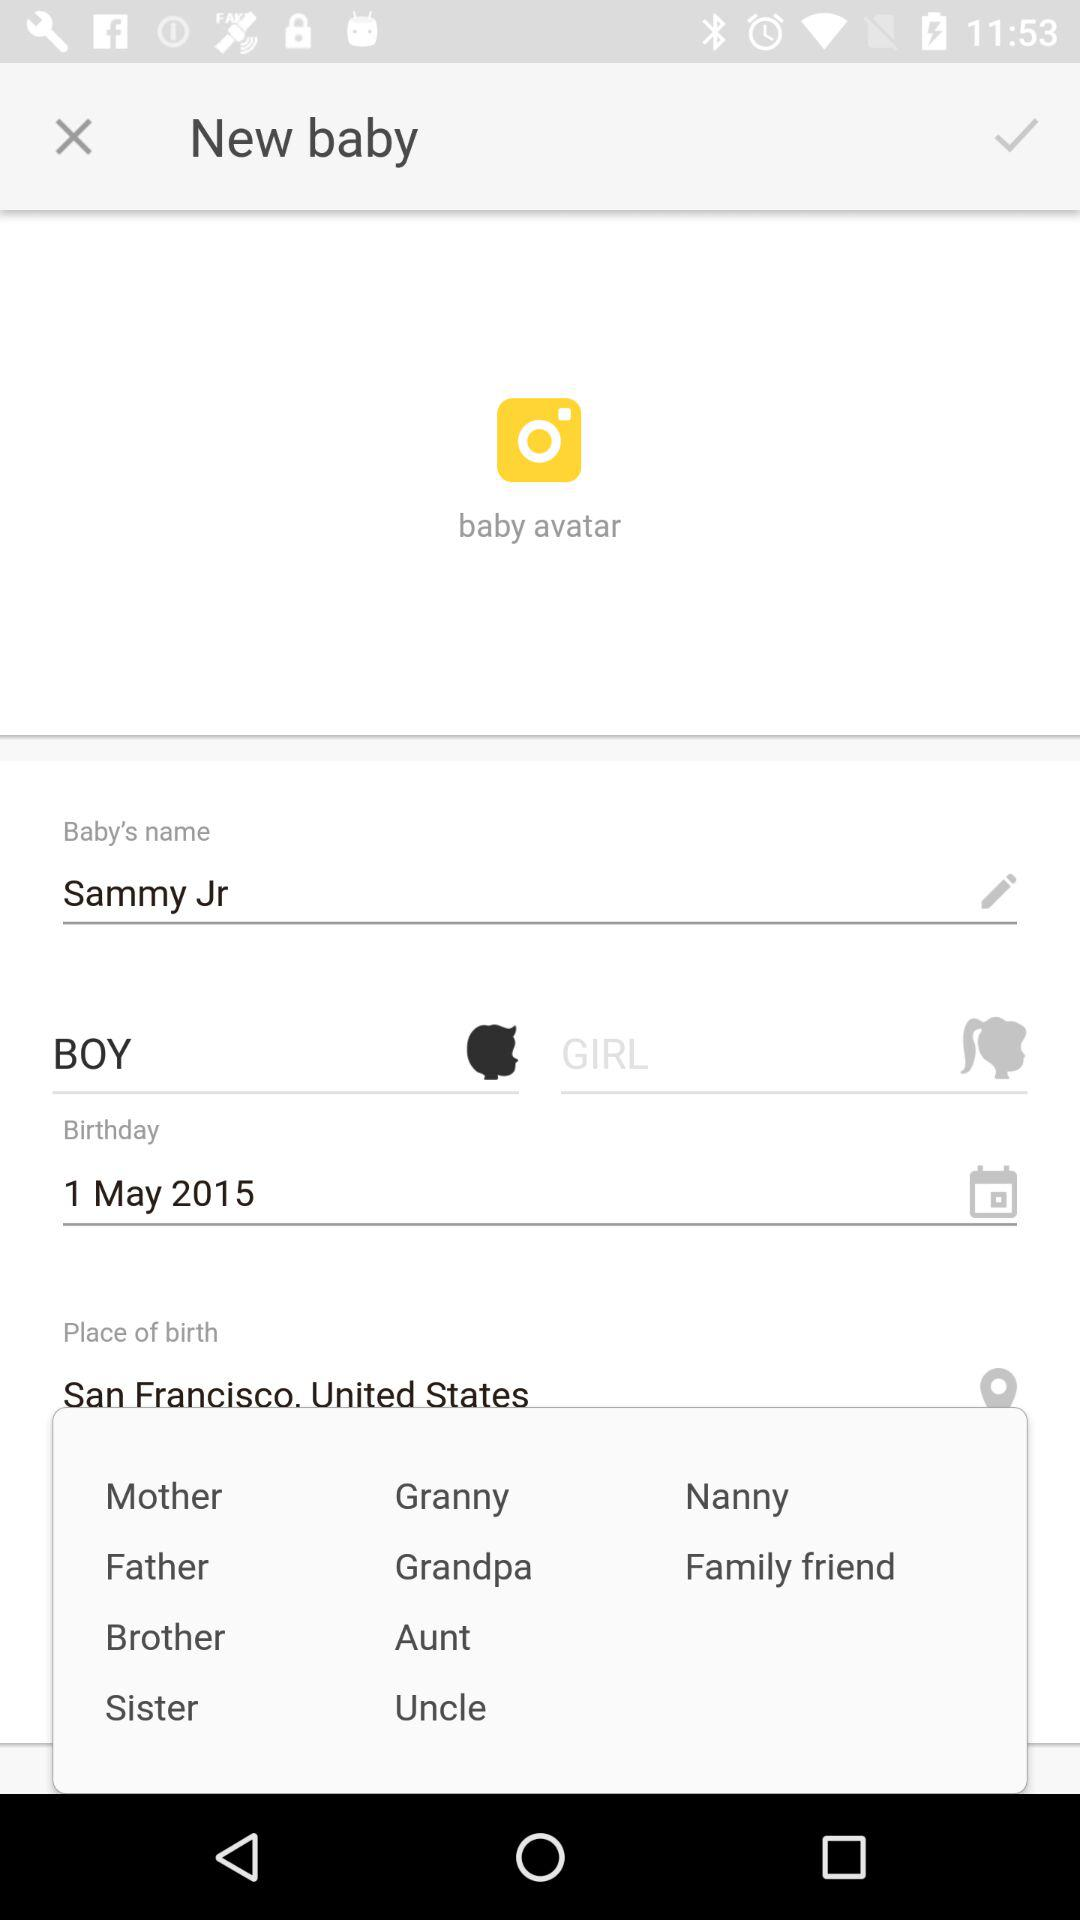What is the gender of the baby?
Answer the question using a single word or phrase. It's a boy. 